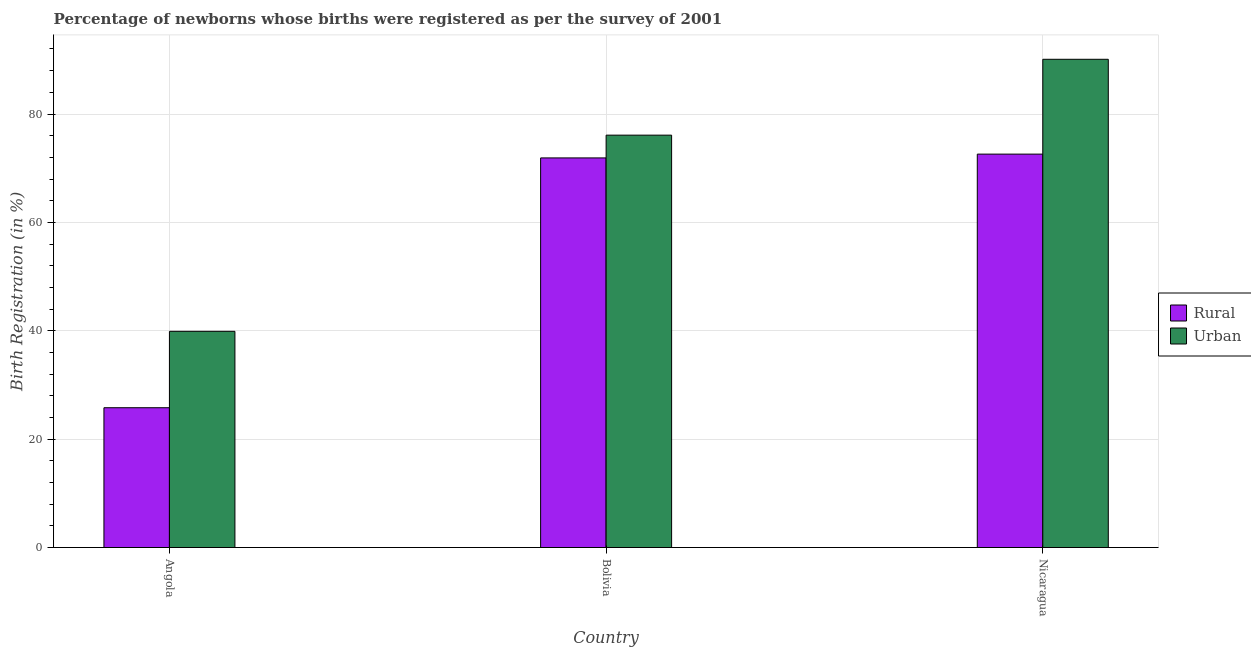How many different coloured bars are there?
Provide a succinct answer. 2. How many groups of bars are there?
Keep it short and to the point. 3. Are the number of bars on each tick of the X-axis equal?
Ensure brevity in your answer.  Yes. How many bars are there on the 3rd tick from the left?
Give a very brief answer. 2. How many bars are there on the 2nd tick from the right?
Ensure brevity in your answer.  2. What is the label of the 3rd group of bars from the left?
Provide a succinct answer. Nicaragua. In how many cases, is the number of bars for a given country not equal to the number of legend labels?
Offer a terse response. 0. What is the rural birth registration in Bolivia?
Your answer should be very brief. 71.9. Across all countries, what is the maximum rural birth registration?
Your answer should be compact. 72.6. Across all countries, what is the minimum rural birth registration?
Your answer should be very brief. 25.8. In which country was the urban birth registration maximum?
Offer a very short reply. Nicaragua. In which country was the rural birth registration minimum?
Provide a succinct answer. Angola. What is the total urban birth registration in the graph?
Offer a terse response. 206.1. What is the difference between the rural birth registration in Bolivia and that in Nicaragua?
Ensure brevity in your answer.  -0.7. What is the difference between the urban birth registration in Bolivia and the rural birth registration in Nicaragua?
Provide a short and direct response. 3.5. What is the average rural birth registration per country?
Give a very brief answer. 56.77. What is the difference between the urban birth registration and rural birth registration in Bolivia?
Your answer should be compact. 4.2. In how many countries, is the rural birth registration greater than 48 %?
Make the answer very short. 2. What is the ratio of the rural birth registration in Angola to that in Bolivia?
Provide a succinct answer. 0.36. What is the difference between the highest and the second highest rural birth registration?
Make the answer very short. 0.7. What is the difference between the highest and the lowest rural birth registration?
Ensure brevity in your answer.  46.8. Is the sum of the urban birth registration in Angola and Bolivia greater than the maximum rural birth registration across all countries?
Offer a very short reply. Yes. What does the 1st bar from the left in Angola represents?
Provide a short and direct response. Rural. What does the 2nd bar from the right in Nicaragua represents?
Your answer should be compact. Rural. Are all the bars in the graph horizontal?
Make the answer very short. No. How many countries are there in the graph?
Provide a short and direct response. 3. Does the graph contain grids?
Give a very brief answer. Yes. How many legend labels are there?
Offer a very short reply. 2. What is the title of the graph?
Offer a very short reply. Percentage of newborns whose births were registered as per the survey of 2001. What is the label or title of the X-axis?
Provide a short and direct response. Country. What is the label or title of the Y-axis?
Give a very brief answer. Birth Registration (in %). What is the Birth Registration (in %) of Rural in Angola?
Offer a very short reply. 25.8. What is the Birth Registration (in %) of Urban in Angola?
Your answer should be very brief. 39.9. What is the Birth Registration (in %) of Rural in Bolivia?
Offer a very short reply. 71.9. What is the Birth Registration (in %) in Urban in Bolivia?
Your answer should be compact. 76.1. What is the Birth Registration (in %) of Rural in Nicaragua?
Ensure brevity in your answer.  72.6. What is the Birth Registration (in %) in Urban in Nicaragua?
Your answer should be very brief. 90.1. Across all countries, what is the maximum Birth Registration (in %) of Rural?
Give a very brief answer. 72.6. Across all countries, what is the maximum Birth Registration (in %) in Urban?
Ensure brevity in your answer.  90.1. Across all countries, what is the minimum Birth Registration (in %) of Rural?
Provide a succinct answer. 25.8. Across all countries, what is the minimum Birth Registration (in %) of Urban?
Offer a terse response. 39.9. What is the total Birth Registration (in %) in Rural in the graph?
Make the answer very short. 170.3. What is the total Birth Registration (in %) of Urban in the graph?
Your answer should be compact. 206.1. What is the difference between the Birth Registration (in %) in Rural in Angola and that in Bolivia?
Ensure brevity in your answer.  -46.1. What is the difference between the Birth Registration (in %) in Urban in Angola and that in Bolivia?
Your answer should be compact. -36.2. What is the difference between the Birth Registration (in %) in Rural in Angola and that in Nicaragua?
Your answer should be very brief. -46.8. What is the difference between the Birth Registration (in %) in Urban in Angola and that in Nicaragua?
Give a very brief answer. -50.2. What is the difference between the Birth Registration (in %) of Urban in Bolivia and that in Nicaragua?
Your response must be concise. -14. What is the difference between the Birth Registration (in %) in Rural in Angola and the Birth Registration (in %) in Urban in Bolivia?
Offer a terse response. -50.3. What is the difference between the Birth Registration (in %) in Rural in Angola and the Birth Registration (in %) in Urban in Nicaragua?
Give a very brief answer. -64.3. What is the difference between the Birth Registration (in %) in Rural in Bolivia and the Birth Registration (in %) in Urban in Nicaragua?
Ensure brevity in your answer.  -18.2. What is the average Birth Registration (in %) in Rural per country?
Provide a short and direct response. 56.77. What is the average Birth Registration (in %) of Urban per country?
Ensure brevity in your answer.  68.7. What is the difference between the Birth Registration (in %) of Rural and Birth Registration (in %) of Urban in Angola?
Make the answer very short. -14.1. What is the difference between the Birth Registration (in %) in Rural and Birth Registration (in %) in Urban in Nicaragua?
Ensure brevity in your answer.  -17.5. What is the ratio of the Birth Registration (in %) of Rural in Angola to that in Bolivia?
Make the answer very short. 0.36. What is the ratio of the Birth Registration (in %) in Urban in Angola to that in Bolivia?
Provide a short and direct response. 0.52. What is the ratio of the Birth Registration (in %) in Rural in Angola to that in Nicaragua?
Your answer should be compact. 0.36. What is the ratio of the Birth Registration (in %) of Urban in Angola to that in Nicaragua?
Provide a succinct answer. 0.44. What is the ratio of the Birth Registration (in %) of Rural in Bolivia to that in Nicaragua?
Keep it short and to the point. 0.99. What is the ratio of the Birth Registration (in %) in Urban in Bolivia to that in Nicaragua?
Keep it short and to the point. 0.84. What is the difference between the highest and the second highest Birth Registration (in %) in Rural?
Give a very brief answer. 0.7. What is the difference between the highest and the second highest Birth Registration (in %) in Urban?
Ensure brevity in your answer.  14. What is the difference between the highest and the lowest Birth Registration (in %) of Rural?
Make the answer very short. 46.8. What is the difference between the highest and the lowest Birth Registration (in %) in Urban?
Your answer should be compact. 50.2. 